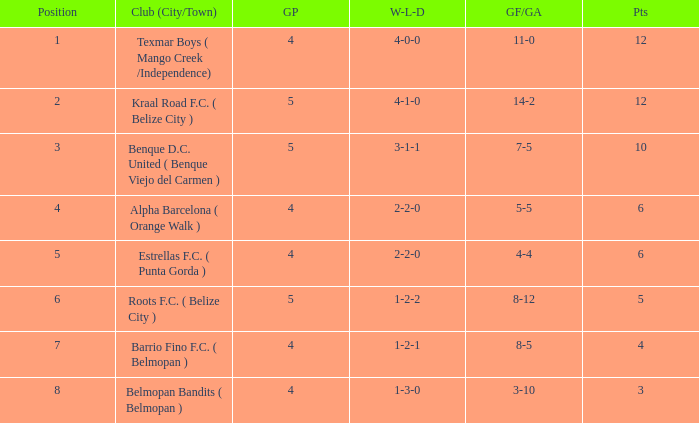What is the minimum points with goals for/against being 8-5 4.0. 